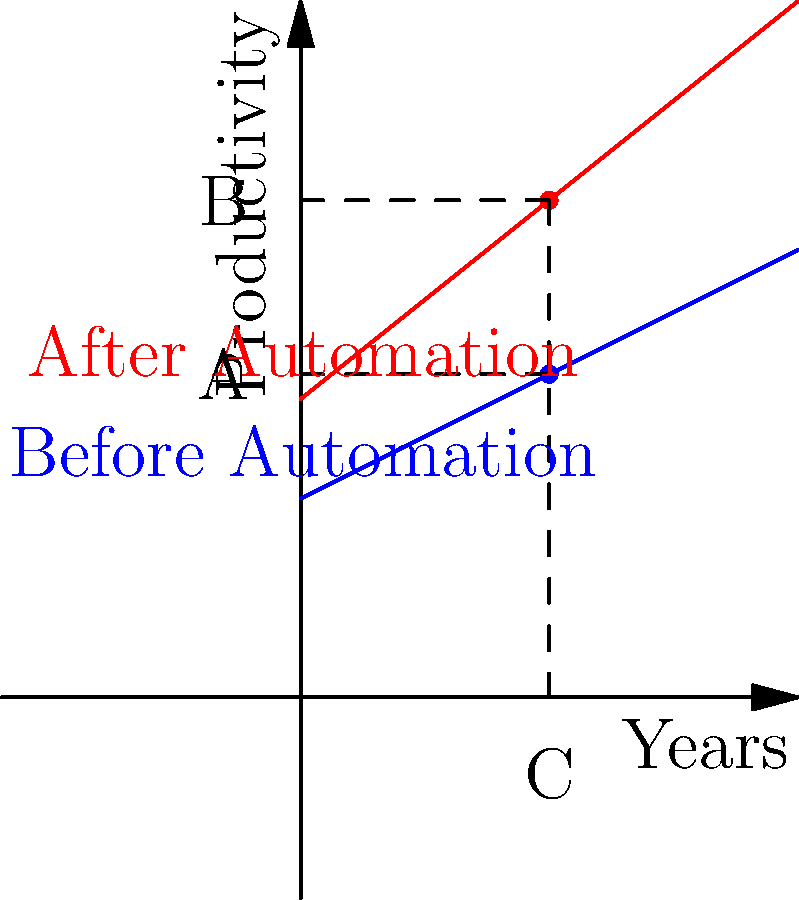The graph shows employee productivity trends before and after automation implementation. At point C (2.5 years), what is the percentage increase in productivity due to automation? To calculate the percentage increase in productivity due to automation at 2.5 years:

1. Identify productivity values:
   - Before automation (blue line) at point A: $0.5 * 2.5 + 2 = 3.25$
   - After automation (red line) at point B: $0.8 * 2.5 + 3 = 5$

2. Calculate the difference:
   $5 - 3.25 = 1.75$

3. Calculate the percentage increase:
   $\text{Percentage increase} = \frac{\text{Increase}}{\text{Original Value}} \times 100\%$
   $= \frac{1.75}{3.25} \times 100\% = 53.85\%$

4. Round to the nearest whole percentage:
   $53.85\% \approx 54\%$
Answer: 54% 